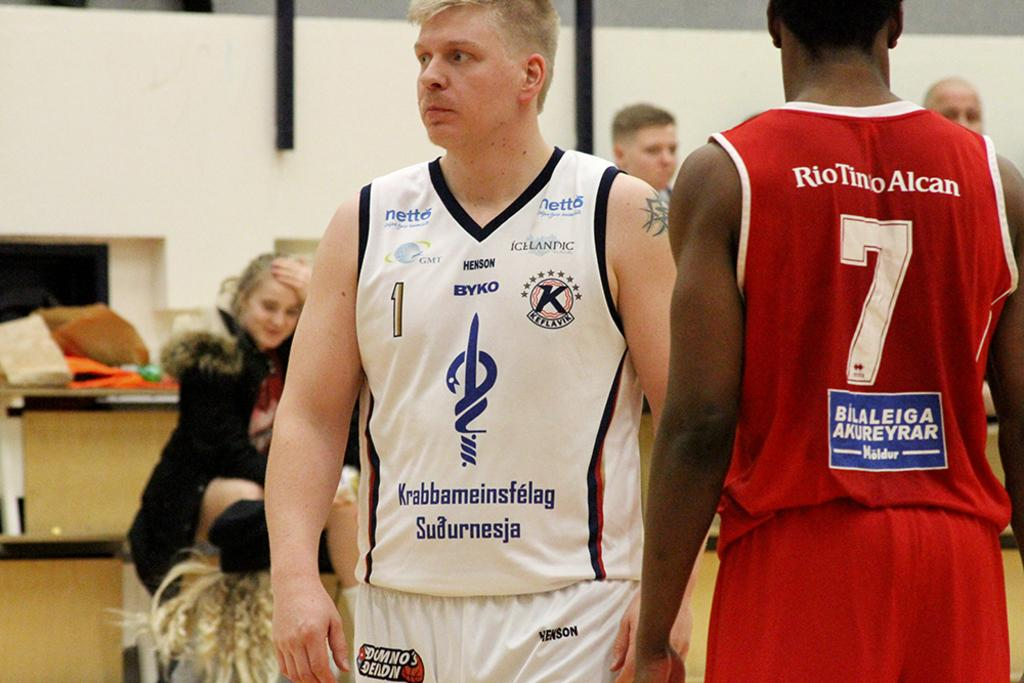<image>
Relay a brief, clear account of the picture shown. Player number 7 has a red uniform on. 